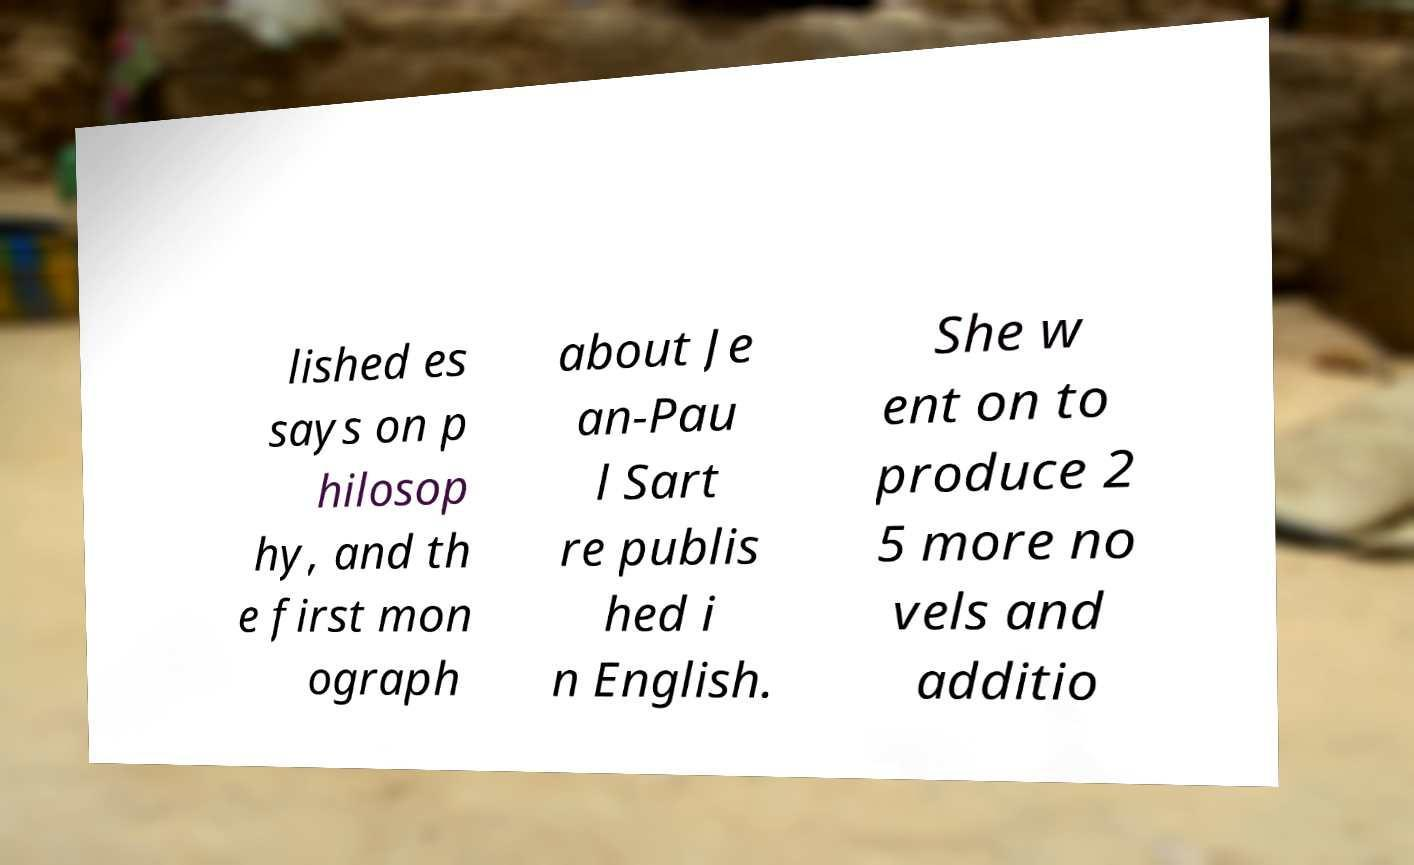Can you read and provide the text displayed in the image?This photo seems to have some interesting text. Can you extract and type it out for me? lished es says on p hilosop hy, and th e first mon ograph about Je an-Pau l Sart re publis hed i n English. She w ent on to produce 2 5 more no vels and additio 